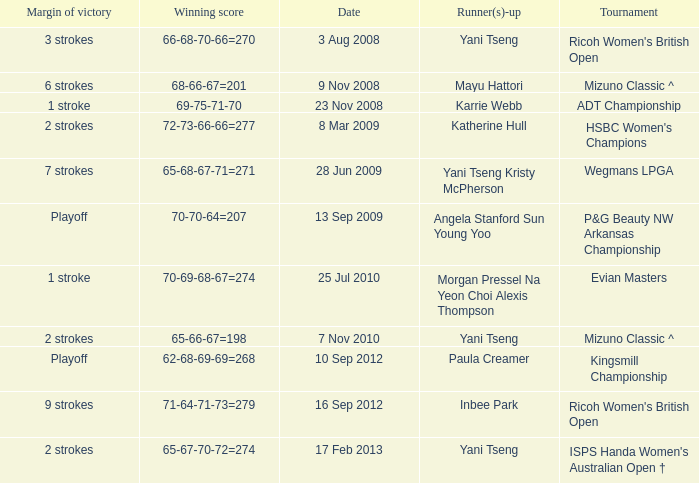What tournament had a victory of a 1 stroke margin and the final winning score 69-75-71-70? ADT Championship. 